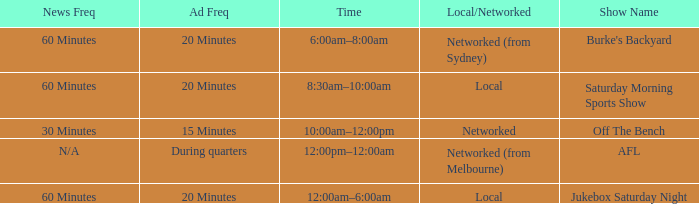What is the ad frequency for the Show Off The Bench? 15 Minutes. 